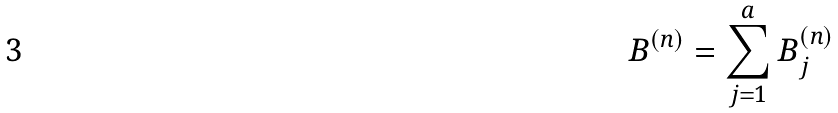<formula> <loc_0><loc_0><loc_500><loc_500>B ^ { ( n ) } = \sum _ { j = 1 } ^ { a } B _ { j } ^ { ( n ) }</formula> 